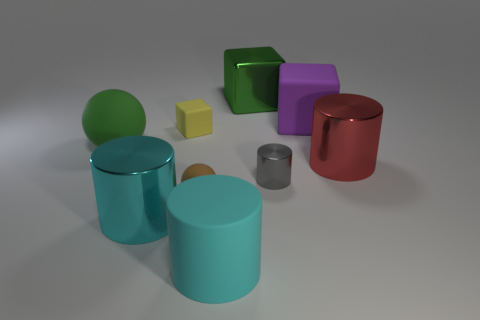Can you tell me what colors the cubes are in this image? In the image, there are two cubes; one is yellow and the other is purple. 